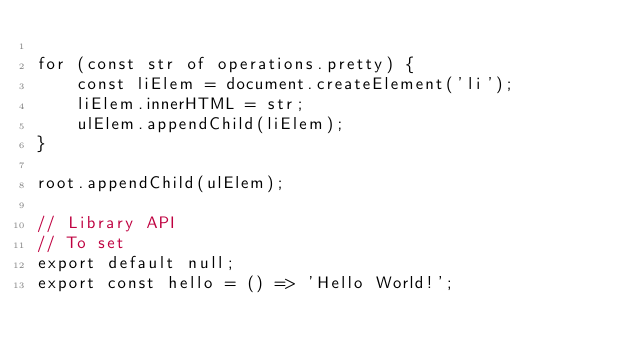Convert code to text. <code><loc_0><loc_0><loc_500><loc_500><_JavaScript_>
for (const str of operations.pretty) {
    const liElem = document.createElement('li');
    liElem.innerHTML = str;
    ulElem.appendChild(liElem);
}

root.appendChild(ulElem);

// Library API
// To set
export default null;
export const hello = () => 'Hello World!';
</code> 